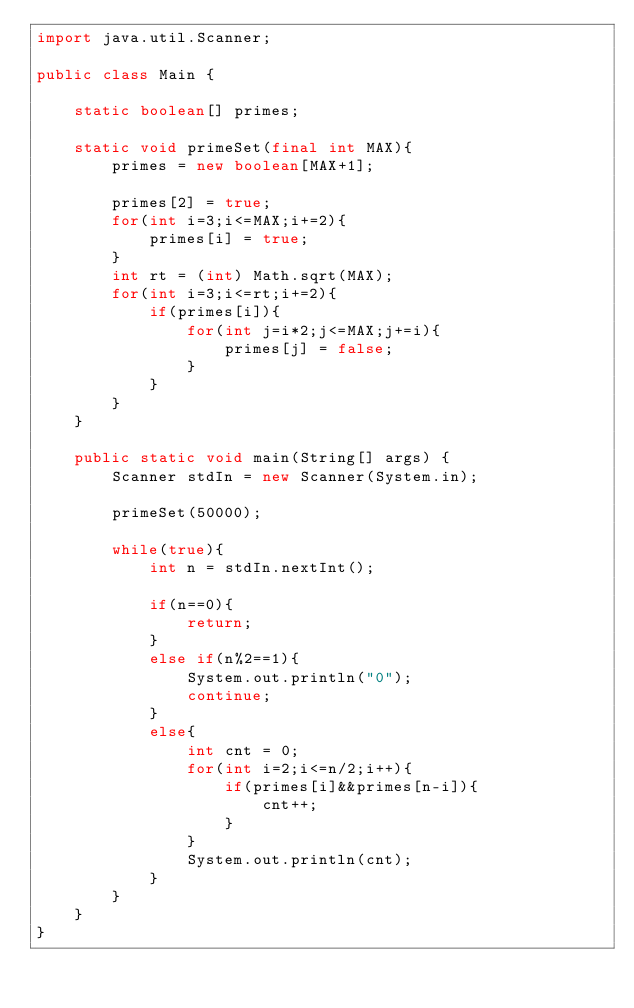Convert code to text. <code><loc_0><loc_0><loc_500><loc_500><_Java_>import java.util.Scanner;

public class Main {

	static boolean[] primes;

	static void primeSet(final int MAX){
		primes = new boolean[MAX+1];

		primes[2] = true;
		for(int i=3;i<=MAX;i+=2){
			primes[i] = true;
		}
		int rt = (int) Math.sqrt(MAX);
		for(int i=3;i<=rt;i+=2){
			if(primes[i]){
				for(int j=i*2;j<=MAX;j+=i){
					primes[j] = false;
				}
			}
		}
	}

	public static void main(String[] args) {
		Scanner stdIn = new Scanner(System.in);

		primeSet(50000);

		while(true){
			int n = stdIn.nextInt();

			if(n==0){
				return;
			}
			else if(n%2==1){
				System.out.println("0");
				continue;
			}
			else{
				int cnt = 0;
				for(int i=2;i<=n/2;i++){
					if(primes[i]&&primes[n-i]){
						cnt++;
					}
				}
				System.out.println(cnt);
			}
		}
	}
}</code> 